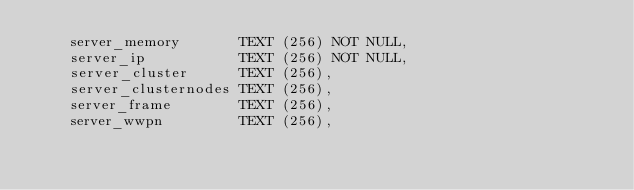Convert code to text. <code><loc_0><loc_0><loc_500><loc_500><_SQL_>    server_memory       TEXT (256) NOT NULL,
    server_ip           TEXT (256) NOT NULL,
    server_cluster      TEXT (256),
    server_clusternodes TEXT (256),
    server_frame        TEXT (256),
    server_wwpn         TEXT (256),</code> 